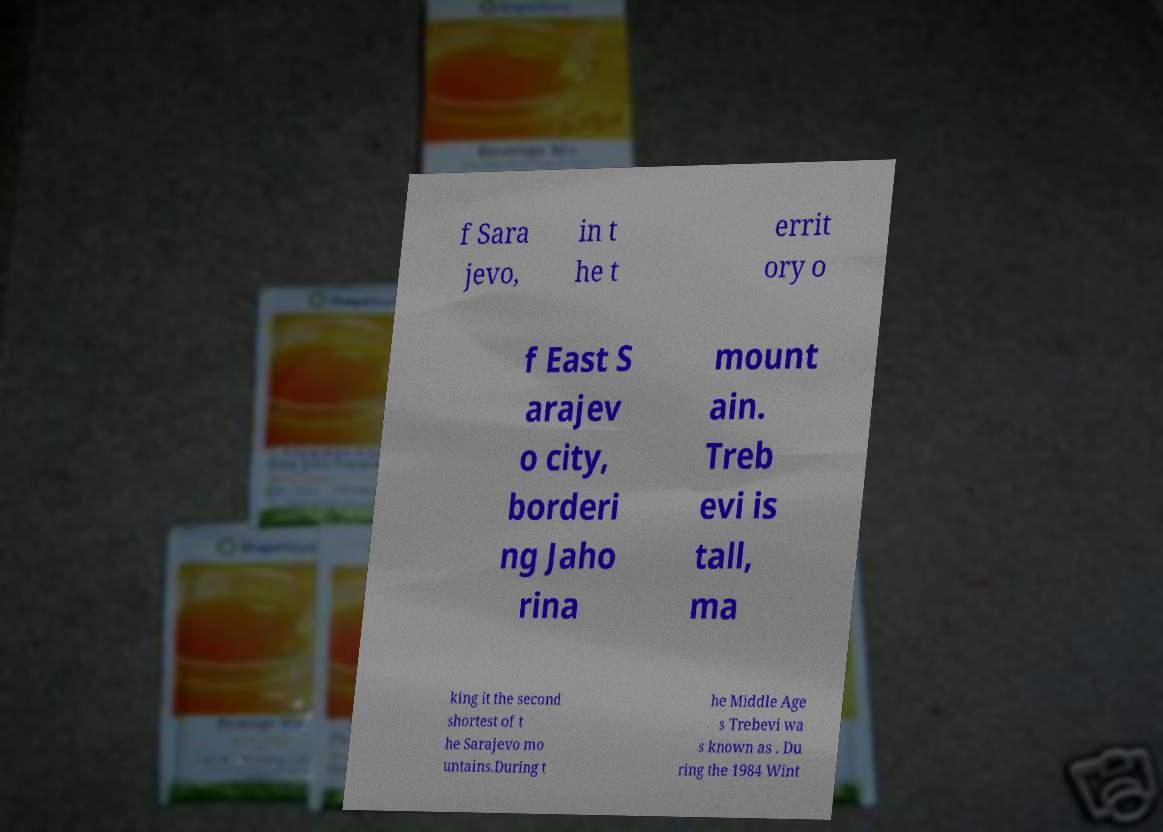There's text embedded in this image that I need extracted. Can you transcribe it verbatim? f Sara jevo, in t he t errit ory o f East S arajev o city, borderi ng Jaho rina mount ain. Treb evi is tall, ma king it the second shortest of t he Sarajevo mo untains.During t he Middle Age s Trebevi wa s known as . Du ring the 1984 Wint 